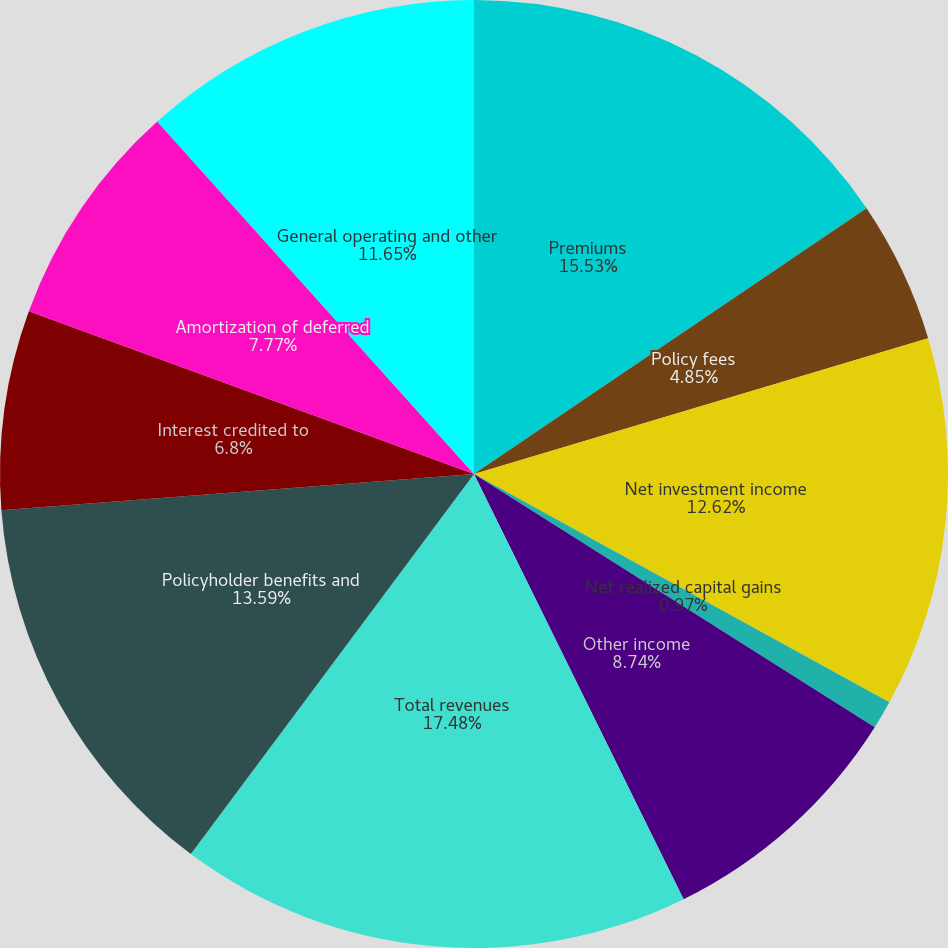<chart> <loc_0><loc_0><loc_500><loc_500><pie_chart><fcel>Premiums<fcel>Policy fees<fcel>Net investment income<fcel>Net realized capital gains<fcel>Other income<fcel>Total revenues<fcel>Policyholder benefits and<fcel>Interest credited to<fcel>Amortization of deferred<fcel>General operating and other<nl><fcel>15.53%<fcel>4.85%<fcel>12.62%<fcel>0.97%<fcel>8.74%<fcel>17.48%<fcel>13.59%<fcel>6.8%<fcel>7.77%<fcel>11.65%<nl></chart> 